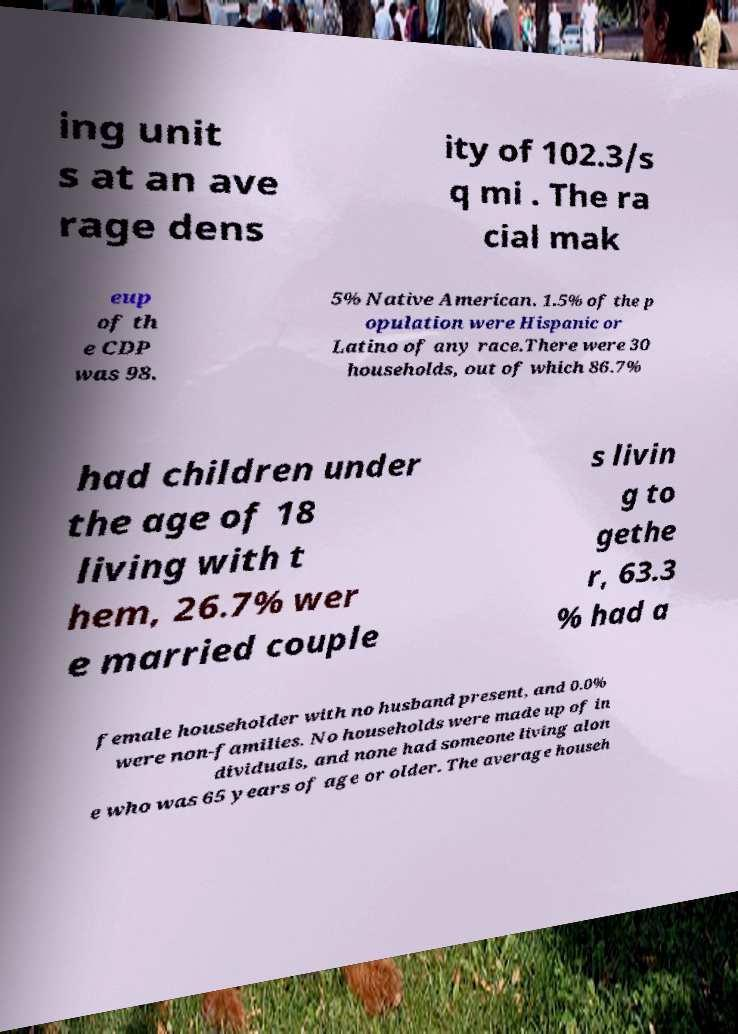There's text embedded in this image that I need extracted. Can you transcribe it verbatim? ing unit s at an ave rage dens ity of 102.3/s q mi . The ra cial mak eup of th e CDP was 98. 5% Native American. 1.5% of the p opulation were Hispanic or Latino of any race.There were 30 households, out of which 86.7% had children under the age of 18 living with t hem, 26.7% wer e married couple s livin g to gethe r, 63.3 % had a female householder with no husband present, and 0.0% were non-families. No households were made up of in dividuals, and none had someone living alon e who was 65 years of age or older. The average househ 